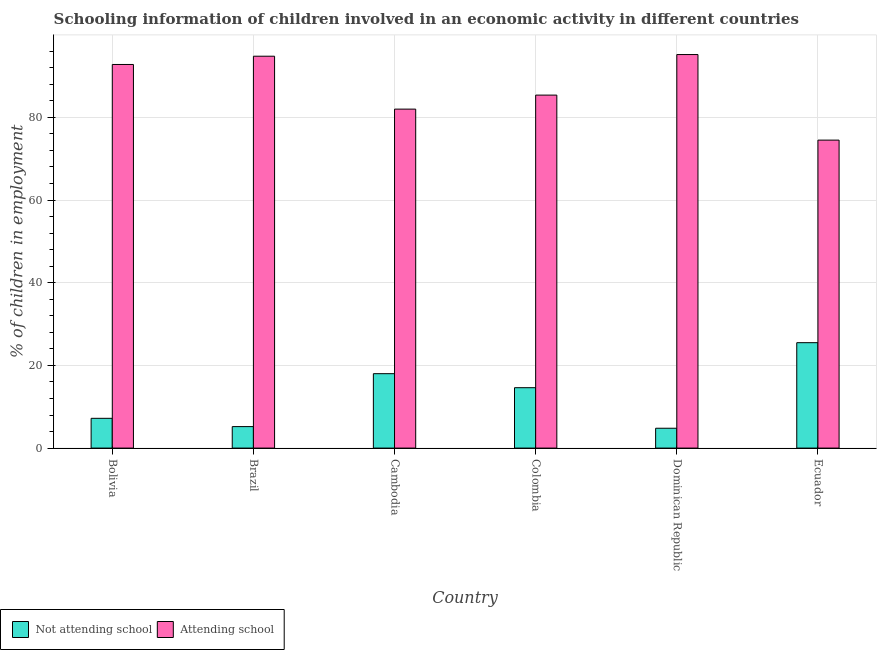Are the number of bars per tick equal to the number of legend labels?
Provide a short and direct response. Yes. Are the number of bars on each tick of the X-axis equal?
Your response must be concise. Yes. What is the label of the 2nd group of bars from the left?
Your answer should be very brief. Brazil. In how many cases, is the number of bars for a given country not equal to the number of legend labels?
Offer a terse response. 0. What is the percentage of employed children who are not attending school in Dominican Republic?
Keep it short and to the point. 4.8. Across all countries, what is the maximum percentage of employed children who are attending school?
Your answer should be compact. 95.2. Across all countries, what is the minimum percentage of employed children who are not attending school?
Provide a short and direct response. 4.8. In which country was the percentage of employed children who are attending school maximum?
Make the answer very short. Dominican Republic. In which country was the percentage of employed children who are not attending school minimum?
Your answer should be compact. Dominican Republic. What is the total percentage of employed children who are not attending school in the graph?
Provide a succinct answer. 75.31. What is the difference between the percentage of employed children who are attending school in Brazil and that in Colombia?
Provide a short and direct response. 9.41. What is the difference between the percentage of employed children who are not attending school in Brazil and the percentage of employed children who are attending school in Colombia?
Offer a terse response. -80.19. What is the average percentage of employed children who are attending school per country?
Your answer should be very brief. 87.45. What is the difference between the percentage of employed children who are attending school and percentage of employed children who are not attending school in Bolivia?
Provide a succinct answer. 85.6. In how many countries, is the percentage of employed children who are attending school greater than 68 %?
Provide a short and direct response. 6. What is the ratio of the percentage of employed children who are not attending school in Brazil to that in Dominican Republic?
Offer a terse response. 1.08. Is the percentage of employed children who are attending school in Bolivia less than that in Ecuador?
Your response must be concise. No. Is the difference between the percentage of employed children who are attending school in Brazil and Cambodia greater than the difference between the percentage of employed children who are not attending school in Brazil and Cambodia?
Keep it short and to the point. Yes. What is the difference between the highest and the lowest percentage of employed children who are not attending school?
Your answer should be very brief. 20.7. In how many countries, is the percentage of employed children who are not attending school greater than the average percentage of employed children who are not attending school taken over all countries?
Give a very brief answer. 3. What does the 1st bar from the left in Bolivia represents?
Offer a very short reply. Not attending school. What does the 1st bar from the right in Cambodia represents?
Ensure brevity in your answer.  Attending school. Are the values on the major ticks of Y-axis written in scientific E-notation?
Your response must be concise. No. Does the graph contain any zero values?
Provide a short and direct response. No. How are the legend labels stacked?
Your answer should be compact. Horizontal. What is the title of the graph?
Keep it short and to the point. Schooling information of children involved in an economic activity in different countries. Does "Services" appear as one of the legend labels in the graph?
Make the answer very short. No. What is the label or title of the Y-axis?
Provide a succinct answer. % of children in employment. What is the % of children in employment in Not attending school in Bolivia?
Offer a very short reply. 7.2. What is the % of children in employment in Attending school in Bolivia?
Ensure brevity in your answer.  92.8. What is the % of children in employment of Not attending school in Brazil?
Make the answer very short. 5.2. What is the % of children in employment of Attending school in Brazil?
Offer a very short reply. 94.8. What is the % of children in employment of Not attending school in Cambodia?
Offer a terse response. 18. What is the % of children in employment of Not attending school in Colombia?
Offer a very short reply. 14.61. What is the % of children in employment of Attending school in Colombia?
Give a very brief answer. 85.39. What is the % of children in employment in Not attending school in Dominican Republic?
Give a very brief answer. 4.8. What is the % of children in employment in Attending school in Dominican Republic?
Give a very brief answer. 95.2. What is the % of children in employment of Attending school in Ecuador?
Your answer should be very brief. 74.5. Across all countries, what is the maximum % of children in employment in Not attending school?
Give a very brief answer. 25.5. Across all countries, what is the maximum % of children in employment of Attending school?
Keep it short and to the point. 95.2. Across all countries, what is the minimum % of children in employment of Not attending school?
Make the answer very short. 4.8. Across all countries, what is the minimum % of children in employment of Attending school?
Provide a short and direct response. 74.5. What is the total % of children in employment of Not attending school in the graph?
Give a very brief answer. 75.31. What is the total % of children in employment of Attending school in the graph?
Give a very brief answer. 524.69. What is the difference between the % of children in employment in Attending school in Bolivia and that in Brazil?
Your answer should be very brief. -2. What is the difference between the % of children in employment of Not attending school in Bolivia and that in Colombia?
Your answer should be very brief. -7.41. What is the difference between the % of children in employment of Attending school in Bolivia and that in Colombia?
Offer a very short reply. 7.41. What is the difference between the % of children in employment of Not attending school in Bolivia and that in Dominican Republic?
Give a very brief answer. 2.4. What is the difference between the % of children in employment in Attending school in Bolivia and that in Dominican Republic?
Provide a succinct answer. -2.4. What is the difference between the % of children in employment in Not attending school in Bolivia and that in Ecuador?
Provide a short and direct response. -18.3. What is the difference between the % of children in employment of Attending school in Bolivia and that in Ecuador?
Your answer should be very brief. 18.3. What is the difference between the % of children in employment of Not attending school in Brazil and that in Cambodia?
Keep it short and to the point. -12.8. What is the difference between the % of children in employment in Attending school in Brazil and that in Cambodia?
Your answer should be compact. 12.8. What is the difference between the % of children in employment in Not attending school in Brazil and that in Colombia?
Your answer should be very brief. -9.41. What is the difference between the % of children in employment in Attending school in Brazil and that in Colombia?
Make the answer very short. 9.41. What is the difference between the % of children in employment of Not attending school in Brazil and that in Dominican Republic?
Ensure brevity in your answer.  0.4. What is the difference between the % of children in employment in Not attending school in Brazil and that in Ecuador?
Keep it short and to the point. -20.3. What is the difference between the % of children in employment in Attending school in Brazil and that in Ecuador?
Offer a very short reply. 20.3. What is the difference between the % of children in employment in Not attending school in Cambodia and that in Colombia?
Provide a succinct answer. 3.39. What is the difference between the % of children in employment of Attending school in Cambodia and that in Colombia?
Provide a succinct answer. -3.39. What is the difference between the % of children in employment of Not attending school in Cambodia and that in Dominican Republic?
Provide a short and direct response. 13.2. What is the difference between the % of children in employment in Attending school in Cambodia and that in Dominican Republic?
Provide a succinct answer. -13.2. What is the difference between the % of children in employment in Attending school in Cambodia and that in Ecuador?
Ensure brevity in your answer.  7.5. What is the difference between the % of children in employment in Not attending school in Colombia and that in Dominican Republic?
Your answer should be compact. 9.81. What is the difference between the % of children in employment of Attending school in Colombia and that in Dominican Republic?
Your response must be concise. -9.81. What is the difference between the % of children in employment of Not attending school in Colombia and that in Ecuador?
Your answer should be compact. -10.89. What is the difference between the % of children in employment in Attending school in Colombia and that in Ecuador?
Your answer should be very brief. 10.89. What is the difference between the % of children in employment of Not attending school in Dominican Republic and that in Ecuador?
Provide a short and direct response. -20.7. What is the difference between the % of children in employment of Attending school in Dominican Republic and that in Ecuador?
Your answer should be compact. 20.7. What is the difference between the % of children in employment in Not attending school in Bolivia and the % of children in employment in Attending school in Brazil?
Your response must be concise. -87.6. What is the difference between the % of children in employment in Not attending school in Bolivia and the % of children in employment in Attending school in Cambodia?
Provide a short and direct response. -74.8. What is the difference between the % of children in employment of Not attending school in Bolivia and the % of children in employment of Attending school in Colombia?
Your answer should be very brief. -78.19. What is the difference between the % of children in employment in Not attending school in Bolivia and the % of children in employment in Attending school in Dominican Republic?
Ensure brevity in your answer.  -88. What is the difference between the % of children in employment in Not attending school in Bolivia and the % of children in employment in Attending school in Ecuador?
Ensure brevity in your answer.  -67.3. What is the difference between the % of children in employment in Not attending school in Brazil and the % of children in employment in Attending school in Cambodia?
Give a very brief answer. -76.8. What is the difference between the % of children in employment in Not attending school in Brazil and the % of children in employment in Attending school in Colombia?
Ensure brevity in your answer.  -80.19. What is the difference between the % of children in employment of Not attending school in Brazil and the % of children in employment of Attending school in Dominican Republic?
Make the answer very short. -90. What is the difference between the % of children in employment of Not attending school in Brazil and the % of children in employment of Attending school in Ecuador?
Your answer should be compact. -69.3. What is the difference between the % of children in employment of Not attending school in Cambodia and the % of children in employment of Attending school in Colombia?
Offer a very short reply. -67.39. What is the difference between the % of children in employment of Not attending school in Cambodia and the % of children in employment of Attending school in Dominican Republic?
Your answer should be compact. -77.2. What is the difference between the % of children in employment of Not attending school in Cambodia and the % of children in employment of Attending school in Ecuador?
Give a very brief answer. -56.5. What is the difference between the % of children in employment in Not attending school in Colombia and the % of children in employment in Attending school in Dominican Republic?
Offer a very short reply. -80.59. What is the difference between the % of children in employment of Not attending school in Colombia and the % of children in employment of Attending school in Ecuador?
Make the answer very short. -59.89. What is the difference between the % of children in employment in Not attending school in Dominican Republic and the % of children in employment in Attending school in Ecuador?
Provide a succinct answer. -69.7. What is the average % of children in employment of Not attending school per country?
Give a very brief answer. 12.55. What is the average % of children in employment in Attending school per country?
Give a very brief answer. 87.45. What is the difference between the % of children in employment in Not attending school and % of children in employment in Attending school in Bolivia?
Make the answer very short. -85.6. What is the difference between the % of children in employment of Not attending school and % of children in employment of Attending school in Brazil?
Provide a short and direct response. -89.6. What is the difference between the % of children in employment of Not attending school and % of children in employment of Attending school in Cambodia?
Your response must be concise. -64. What is the difference between the % of children in employment of Not attending school and % of children in employment of Attending school in Colombia?
Offer a terse response. -70.78. What is the difference between the % of children in employment of Not attending school and % of children in employment of Attending school in Dominican Republic?
Ensure brevity in your answer.  -90.4. What is the difference between the % of children in employment in Not attending school and % of children in employment in Attending school in Ecuador?
Offer a very short reply. -49. What is the ratio of the % of children in employment in Not attending school in Bolivia to that in Brazil?
Your answer should be compact. 1.38. What is the ratio of the % of children in employment in Attending school in Bolivia to that in Brazil?
Ensure brevity in your answer.  0.98. What is the ratio of the % of children in employment of Attending school in Bolivia to that in Cambodia?
Give a very brief answer. 1.13. What is the ratio of the % of children in employment of Not attending school in Bolivia to that in Colombia?
Keep it short and to the point. 0.49. What is the ratio of the % of children in employment of Attending school in Bolivia to that in Colombia?
Offer a very short reply. 1.09. What is the ratio of the % of children in employment of Not attending school in Bolivia to that in Dominican Republic?
Keep it short and to the point. 1.5. What is the ratio of the % of children in employment in Attending school in Bolivia to that in Dominican Republic?
Make the answer very short. 0.97. What is the ratio of the % of children in employment of Not attending school in Bolivia to that in Ecuador?
Give a very brief answer. 0.28. What is the ratio of the % of children in employment of Attending school in Bolivia to that in Ecuador?
Your response must be concise. 1.25. What is the ratio of the % of children in employment in Not attending school in Brazil to that in Cambodia?
Offer a terse response. 0.29. What is the ratio of the % of children in employment of Attending school in Brazil to that in Cambodia?
Your answer should be very brief. 1.16. What is the ratio of the % of children in employment of Not attending school in Brazil to that in Colombia?
Offer a very short reply. 0.36. What is the ratio of the % of children in employment in Attending school in Brazil to that in Colombia?
Keep it short and to the point. 1.11. What is the ratio of the % of children in employment in Attending school in Brazil to that in Dominican Republic?
Offer a very short reply. 1. What is the ratio of the % of children in employment of Not attending school in Brazil to that in Ecuador?
Offer a very short reply. 0.2. What is the ratio of the % of children in employment of Attending school in Brazil to that in Ecuador?
Make the answer very short. 1.27. What is the ratio of the % of children in employment of Not attending school in Cambodia to that in Colombia?
Make the answer very short. 1.23. What is the ratio of the % of children in employment of Attending school in Cambodia to that in Colombia?
Offer a very short reply. 0.96. What is the ratio of the % of children in employment in Not attending school in Cambodia to that in Dominican Republic?
Your answer should be very brief. 3.75. What is the ratio of the % of children in employment in Attending school in Cambodia to that in Dominican Republic?
Ensure brevity in your answer.  0.86. What is the ratio of the % of children in employment in Not attending school in Cambodia to that in Ecuador?
Offer a very short reply. 0.71. What is the ratio of the % of children in employment in Attending school in Cambodia to that in Ecuador?
Provide a succinct answer. 1.1. What is the ratio of the % of children in employment in Not attending school in Colombia to that in Dominican Republic?
Your response must be concise. 3.04. What is the ratio of the % of children in employment in Attending school in Colombia to that in Dominican Republic?
Provide a short and direct response. 0.9. What is the ratio of the % of children in employment of Not attending school in Colombia to that in Ecuador?
Make the answer very short. 0.57. What is the ratio of the % of children in employment in Attending school in Colombia to that in Ecuador?
Provide a succinct answer. 1.15. What is the ratio of the % of children in employment in Not attending school in Dominican Republic to that in Ecuador?
Offer a terse response. 0.19. What is the ratio of the % of children in employment in Attending school in Dominican Republic to that in Ecuador?
Offer a very short reply. 1.28. What is the difference between the highest and the lowest % of children in employment in Not attending school?
Keep it short and to the point. 20.7. What is the difference between the highest and the lowest % of children in employment of Attending school?
Keep it short and to the point. 20.7. 